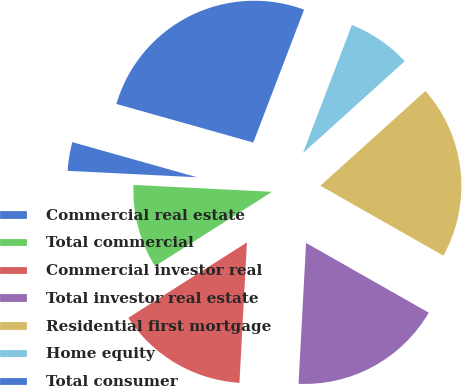Convert chart to OTSL. <chart><loc_0><loc_0><loc_500><loc_500><pie_chart><fcel>Commercial real estate<fcel>Total commercial<fcel>Commercial investor real<fcel>Total investor real estate<fcel>Residential first mortgage<fcel>Home equity<fcel>Total consumer<nl><fcel>3.58%<fcel>9.8%<fcel>15.14%<fcel>17.62%<fcel>19.91%<fcel>7.51%<fcel>26.44%<nl></chart> 